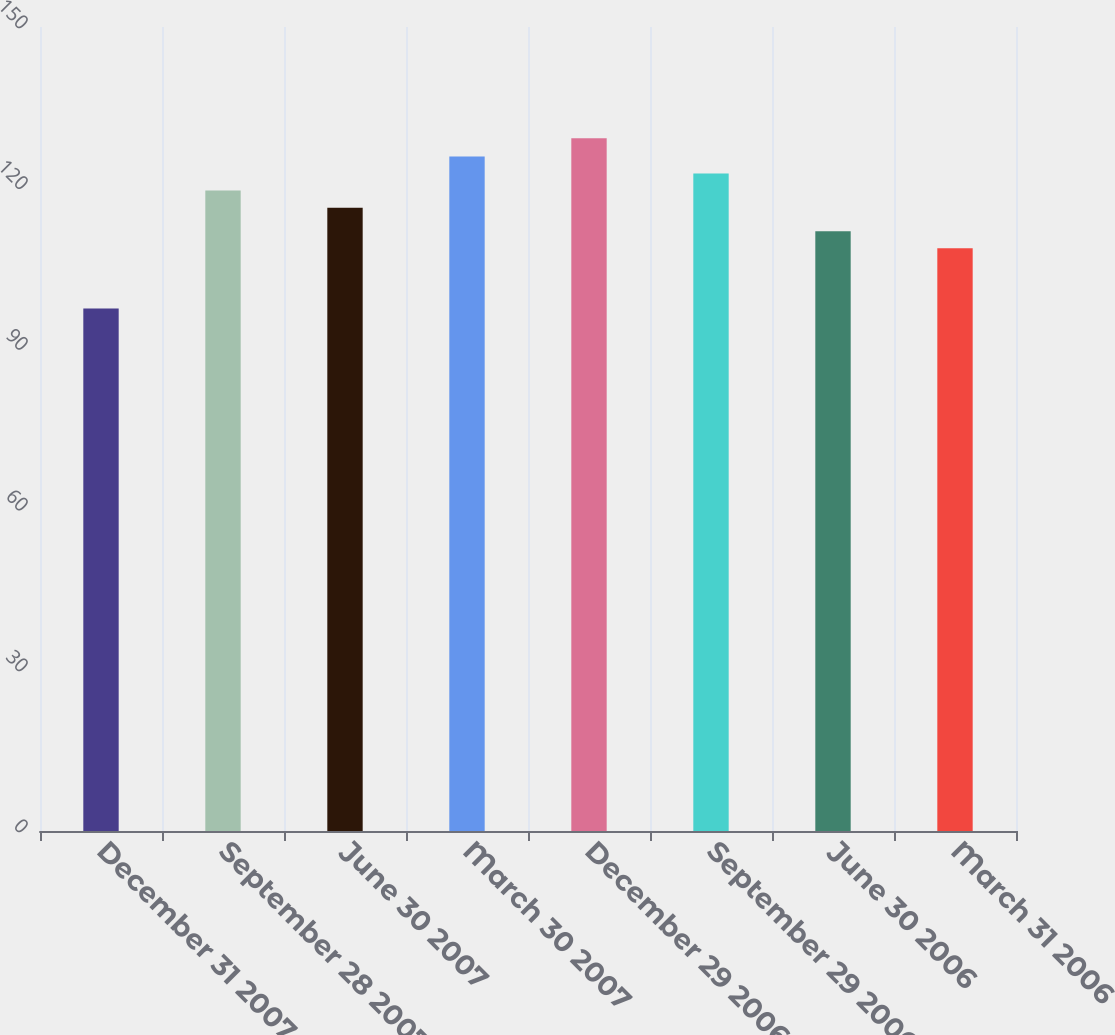Convert chart. <chart><loc_0><loc_0><loc_500><loc_500><bar_chart><fcel>December 31 2007<fcel>September 28 2007<fcel>June 30 2007<fcel>March 30 2007<fcel>December 29 2006<fcel>September 29 2006<fcel>June 30 2006<fcel>March 31 2006<nl><fcel>97.49<fcel>119.48<fcel>116.3<fcel>125.84<fcel>129.25<fcel>122.66<fcel>111.91<fcel>108.73<nl></chart> 